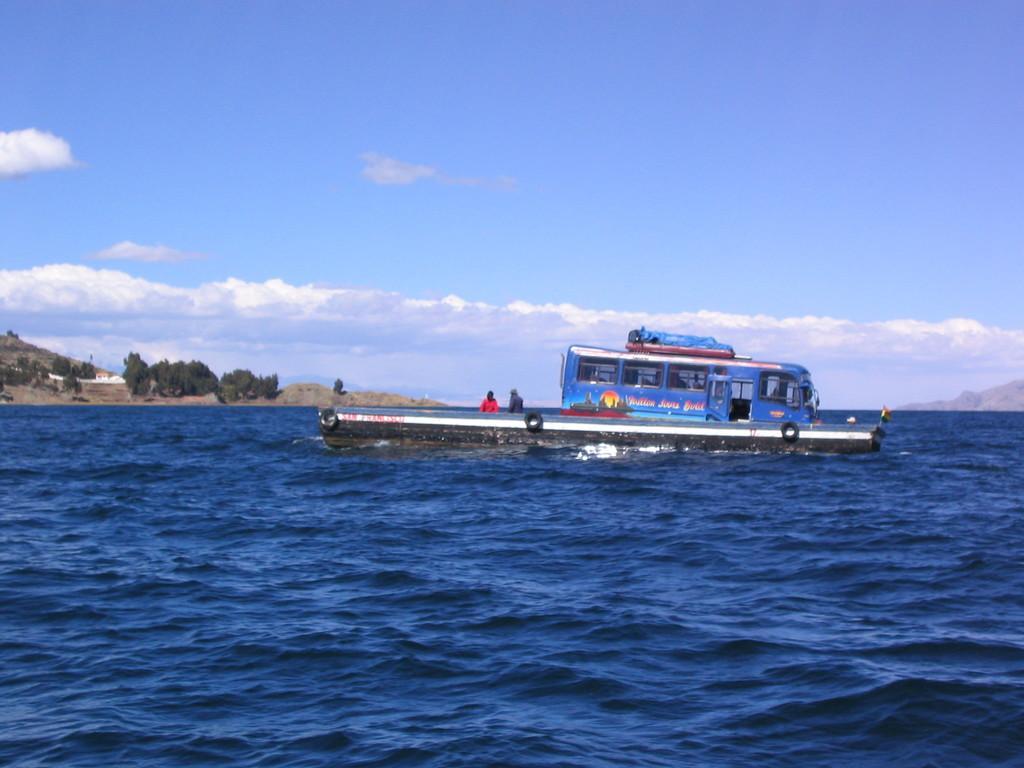Could you give a brief overview of what you see in this image? In the foreground of the picture there is water, in the water there is a boat. On the left there is land and trees. Sky is bit cloudy and it is sunny. On the right there is a hill. 